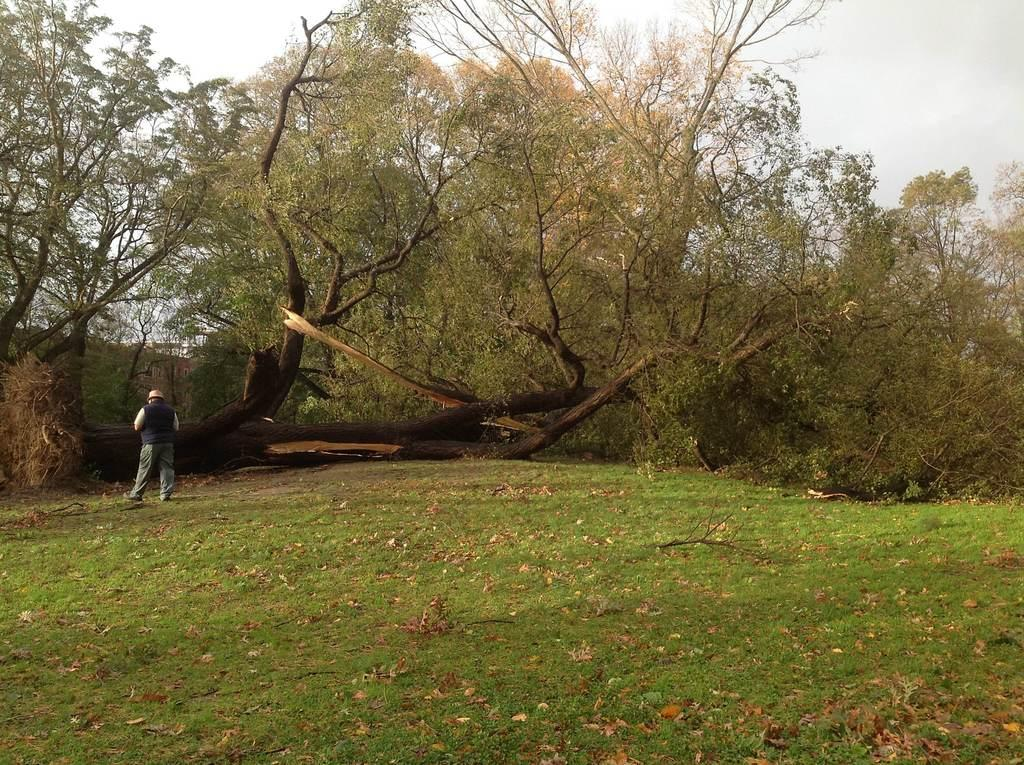What is the person in the image doing? The person is standing in the open area. What type of ground is visible in the image? There is a lawn in the image. What can be seen in the background of the image? There are trees and the sky is visible in the background of the image. How many frogs are sitting on the copy machine in the image? There is no copy machine or frogs present in the image. 